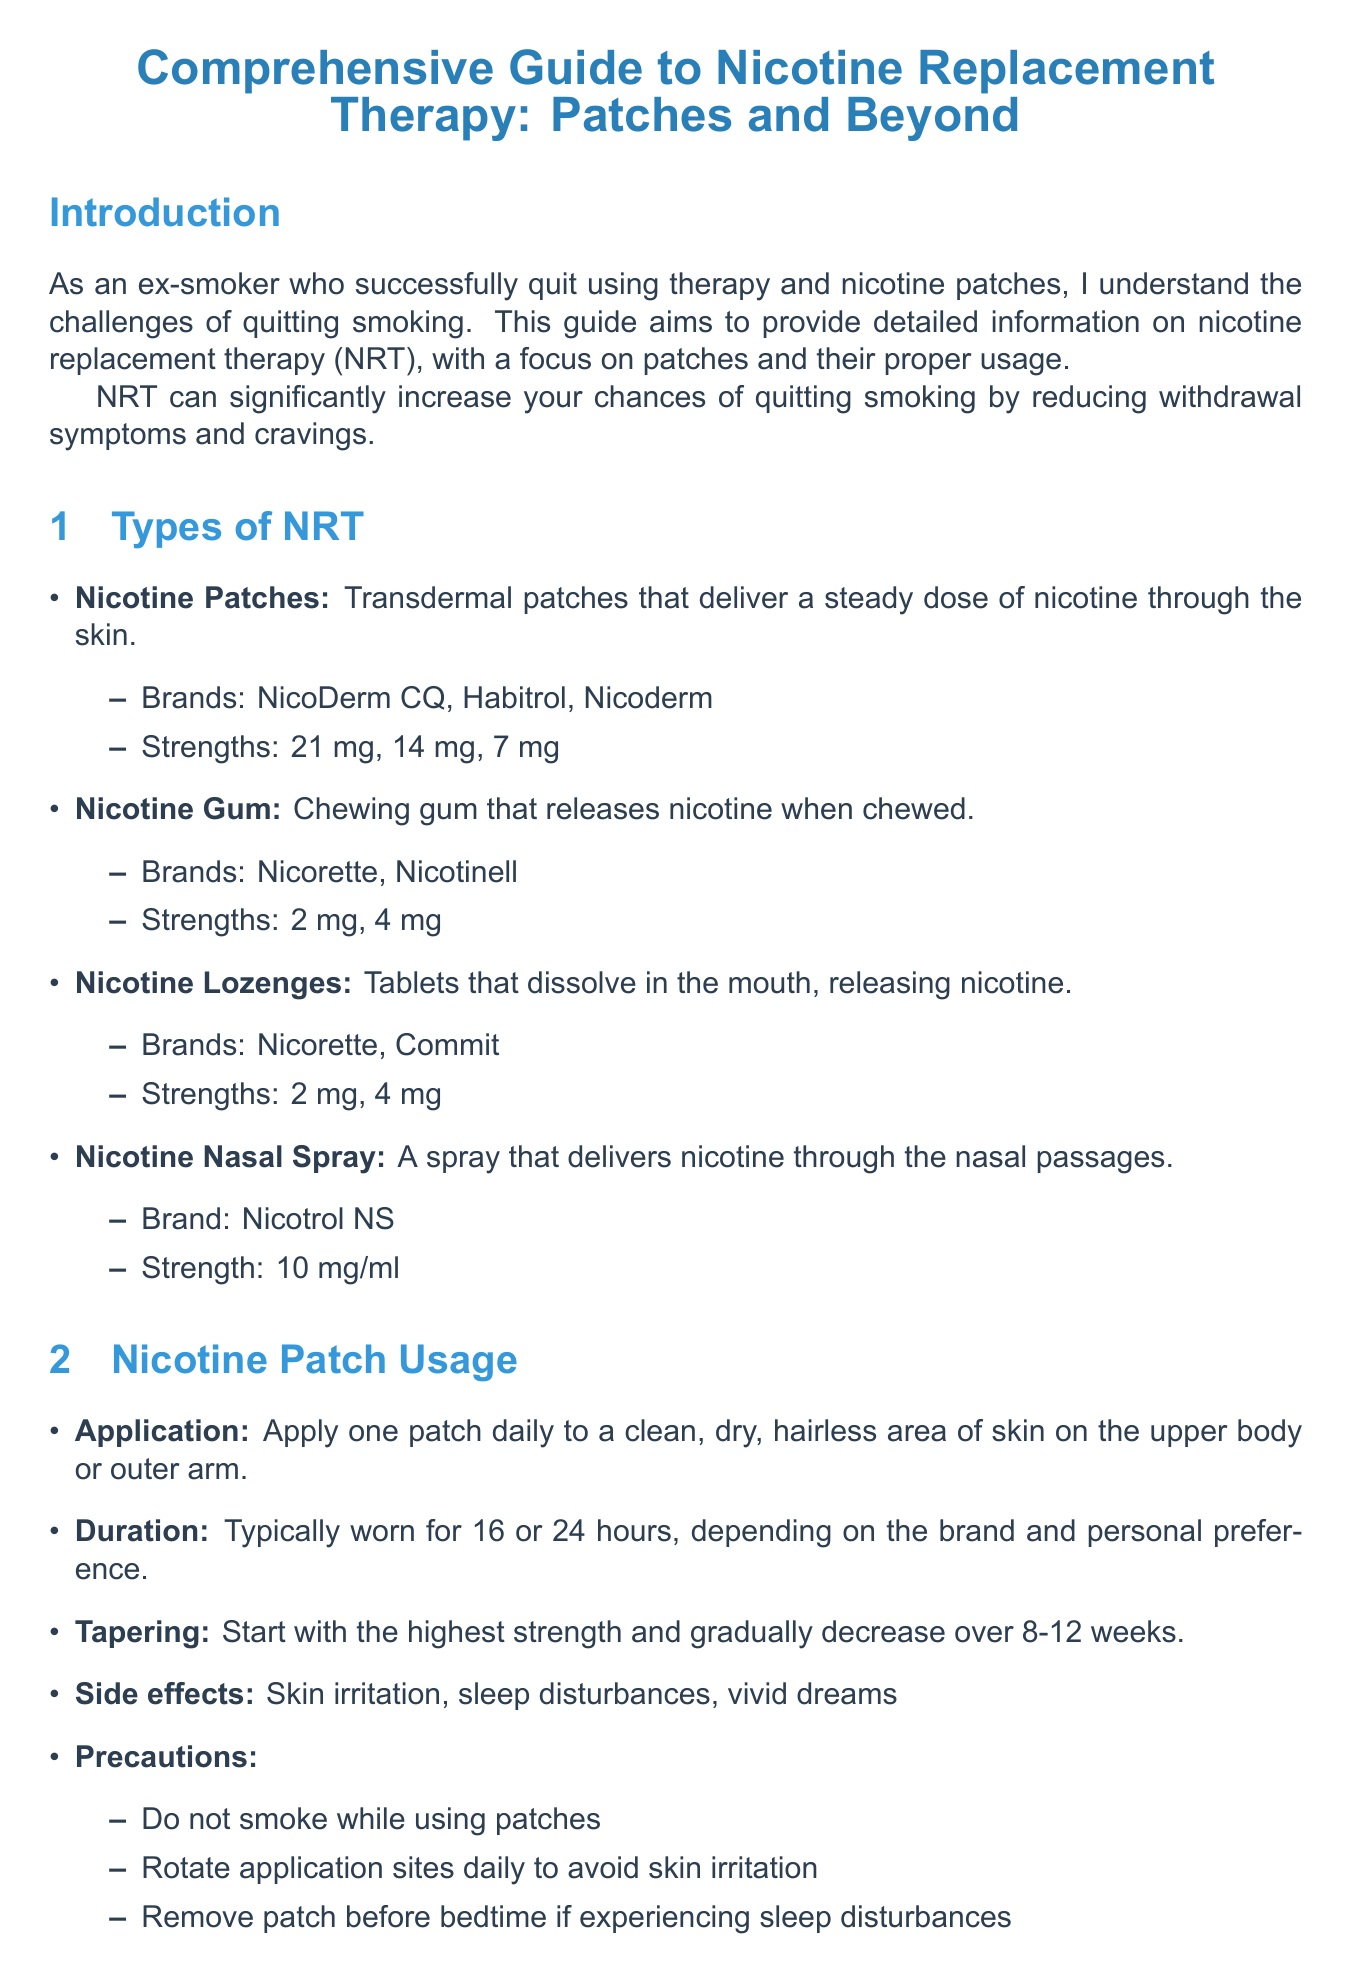What are the strengths available for nicotine patches? The document lists the strengths of nicotine patches as 21 mg, 14 mg, and 7 mg.
Answer: 21 mg, 14 mg, 7 mg What duration do nicotine patches typically have? The document mentions that nicotine patches are typically worn for 16 or 24 hours.
Answer: 16 or 24 hours What precaution is advised while using nicotine patches? The document provides precautions, one of which is to not smoke while using patches.
Answer: Do not smoke while using patches Which therapy type addresses psychological dependence? The document states that Cognitive Behavioral Therapy (CBT) is one of the therapy types that addresses psychological dependence.
Answer: Cognitive Behavioral Therapy (CBT) Can combining NRT methods be more effective? The document suggests that using multiple forms of NRT can be more effective than using a single method.
Answer: Yes What is the importance of combining NRT with therapy? The document states that combining NRT with therapy can significantly improve quit rates.
Answer: Improves quit rates What is one of the tips for success in quitting smoking? The document lists several tips, one of which is to set a quit date and stick to it.
Answer: Set a quit date and stick to it What is a resource for quitting smoking in the US? The document provides the quit line for the US as 1-800-QUIT-NOW.
Answer: 1-800-QUIT-NOW What type of gum releases nicotine? The document lists nicotine gum as a type that releases nicotine when chewed.
Answer: Nicotine Gum 